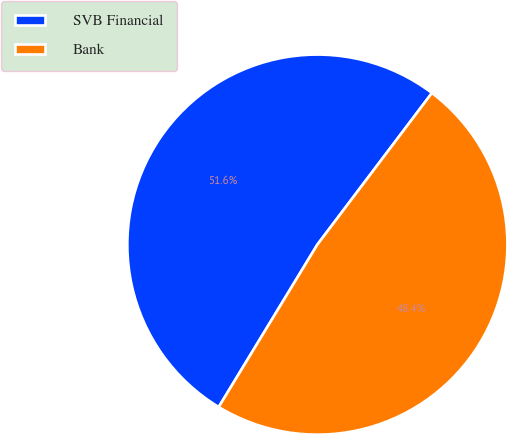Convert chart. <chart><loc_0><loc_0><loc_500><loc_500><pie_chart><fcel>SVB Financial<fcel>Bank<nl><fcel>51.61%<fcel>48.39%<nl></chart> 